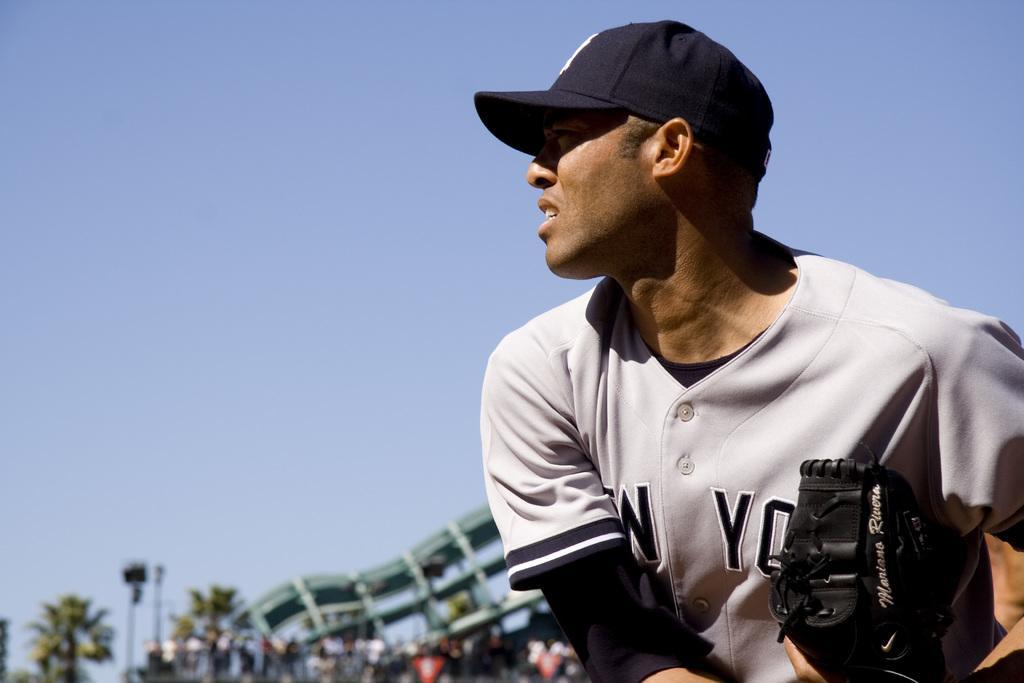Could you give a brief overview of what you see in this image? On the right side of this image there is a man wearing a t-shirt, cap on the head, holding an object in the hand and looking at the left side. In the background there are few people, trees and a building. At the top of the image I can see the sky. 